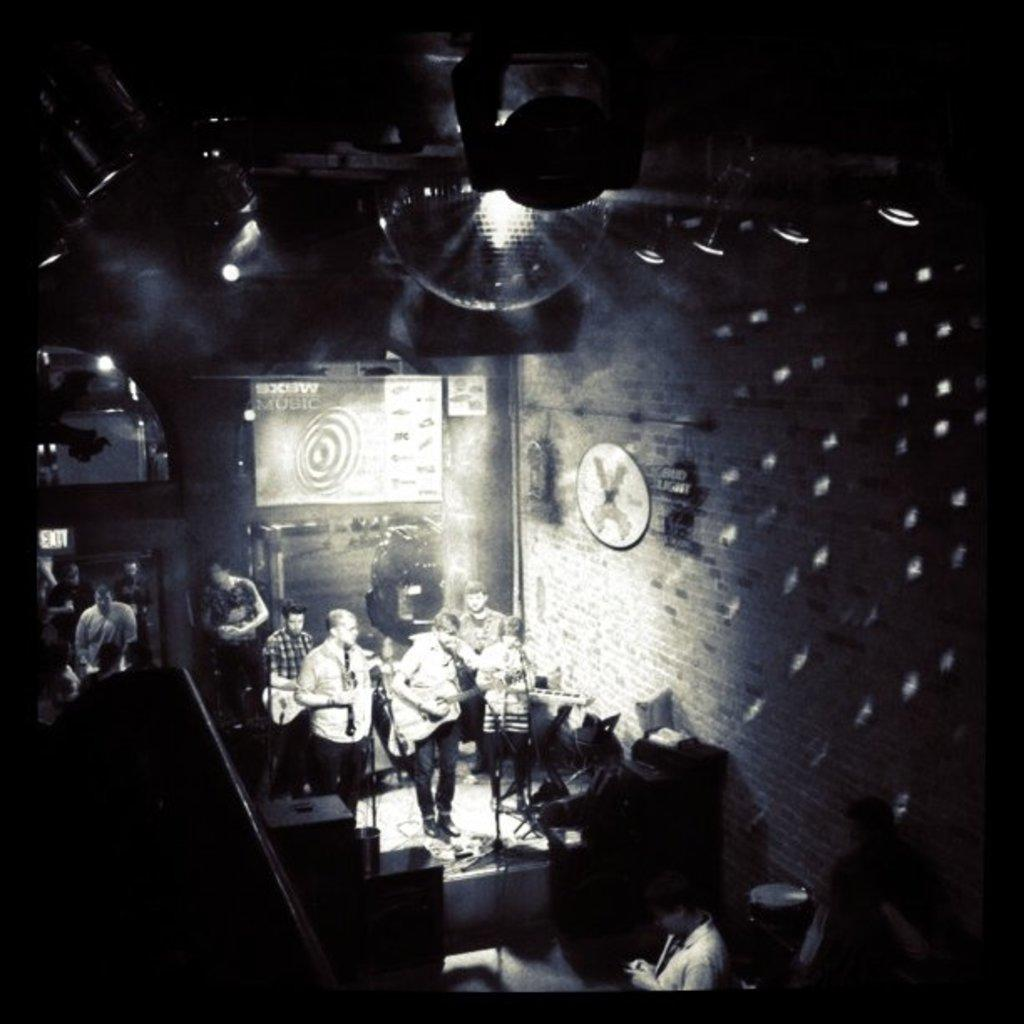What is the color scheme of the image? The image is black and white. What is happening on the stage in the image? There are people performing on a stage in the image. How many rifles are being used by the performers on the stage in the image? There are no rifles present in the image; it features people performing on a stage. 